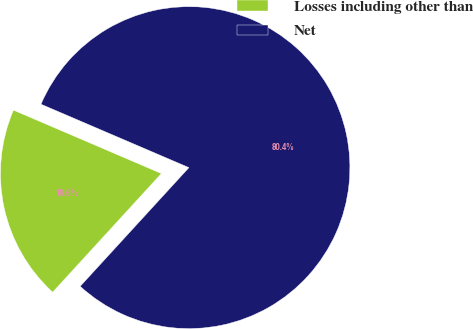<chart> <loc_0><loc_0><loc_500><loc_500><pie_chart><fcel>Losses including other than<fcel>Net<nl><fcel>19.64%<fcel>80.36%<nl></chart> 